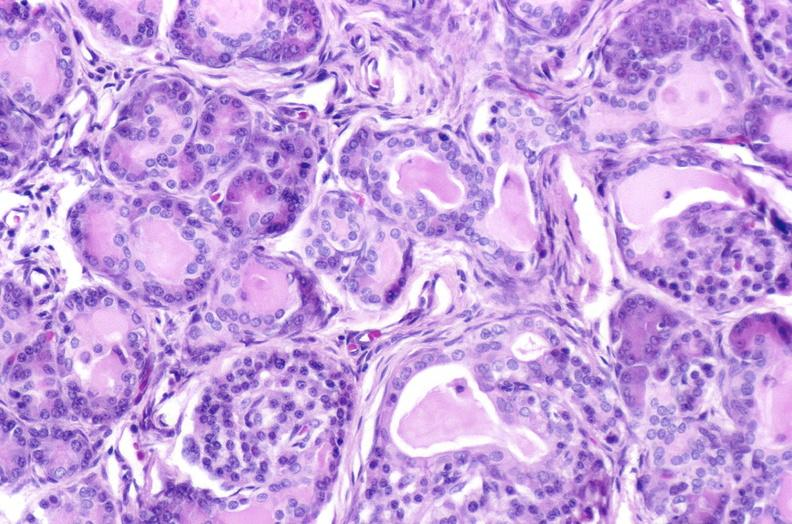does this image show cystic fibrosis?
Answer the question using a single word or phrase. Yes 